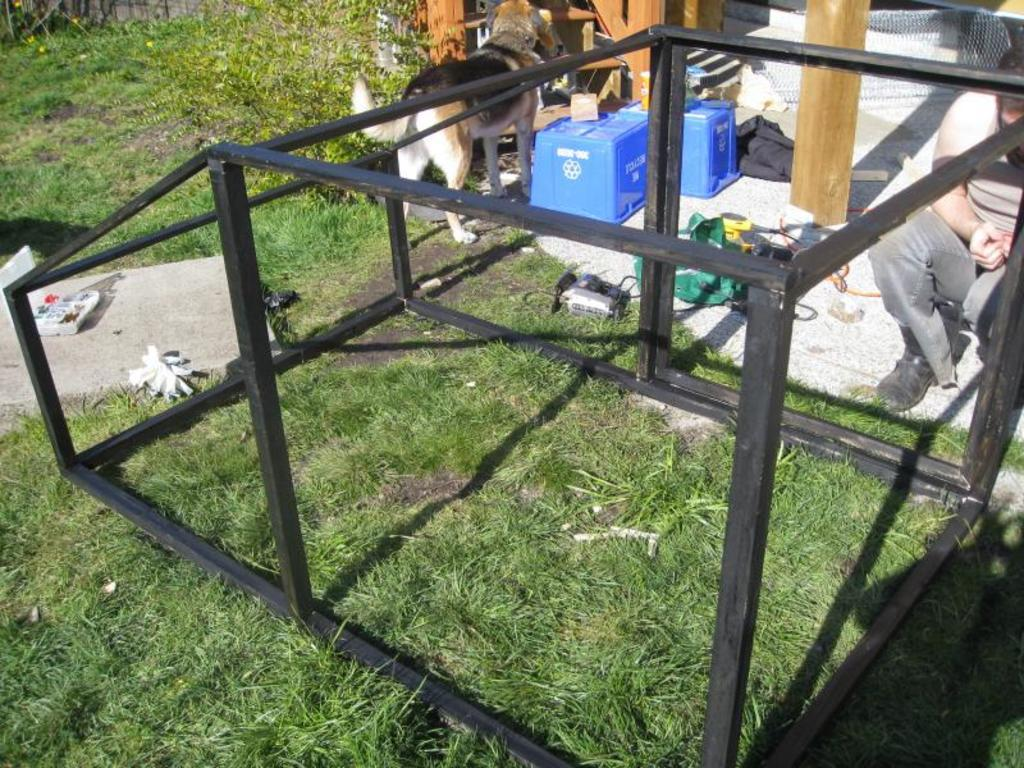What type of surface can be seen in the image? There are roads on the grass in the image. What animal is present at the top of the image? There is a dog at the top of the image. What color are the boxes visible in the image? The blue boxes are visible in the image. What type of vegetation is present in the image? A plant is present in the image. What material are the objects made of in the image? Wooden objects are in the image. What type of structure can be seen in the image? There is a mesh in the image. Can you identify a person in the image? Yes, a person is visible in the image. What type of quartz is used to create the roads in the image? There is no mention of quartz being used to create the roads in the image. How does the person in the image express disgust? The image does not show any expression of disgust by the person. 